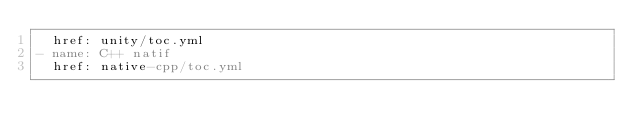Convert code to text. <code><loc_0><loc_0><loc_500><loc_500><_YAML_>  href: unity/toc.yml
- name: C++ natif
  href: native-cpp/toc.yml</code> 